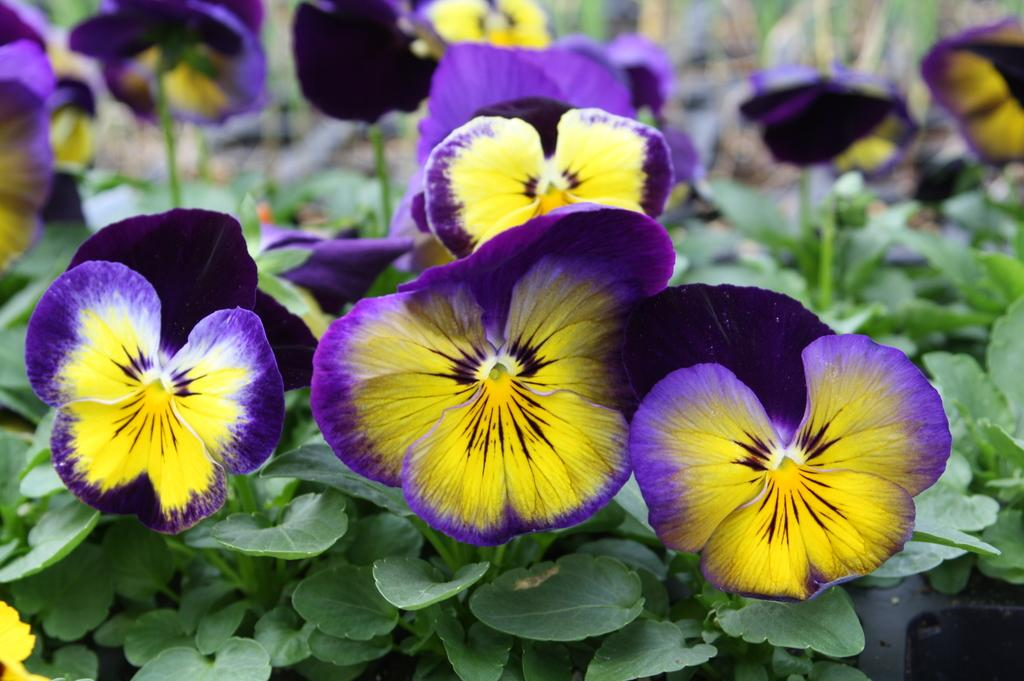What type of living organisms can be seen in the image? Plants can be seen in the image. What specific feature of the plants is visible in the image? The plants have flowers. How many dogs are visible in the image? There are no dogs present in the image; it features plants with flowers. What type of clothing accessory is shown being used on the plants in the image? There is no clothing accessory, such as a zipper or comb, present in the image. 